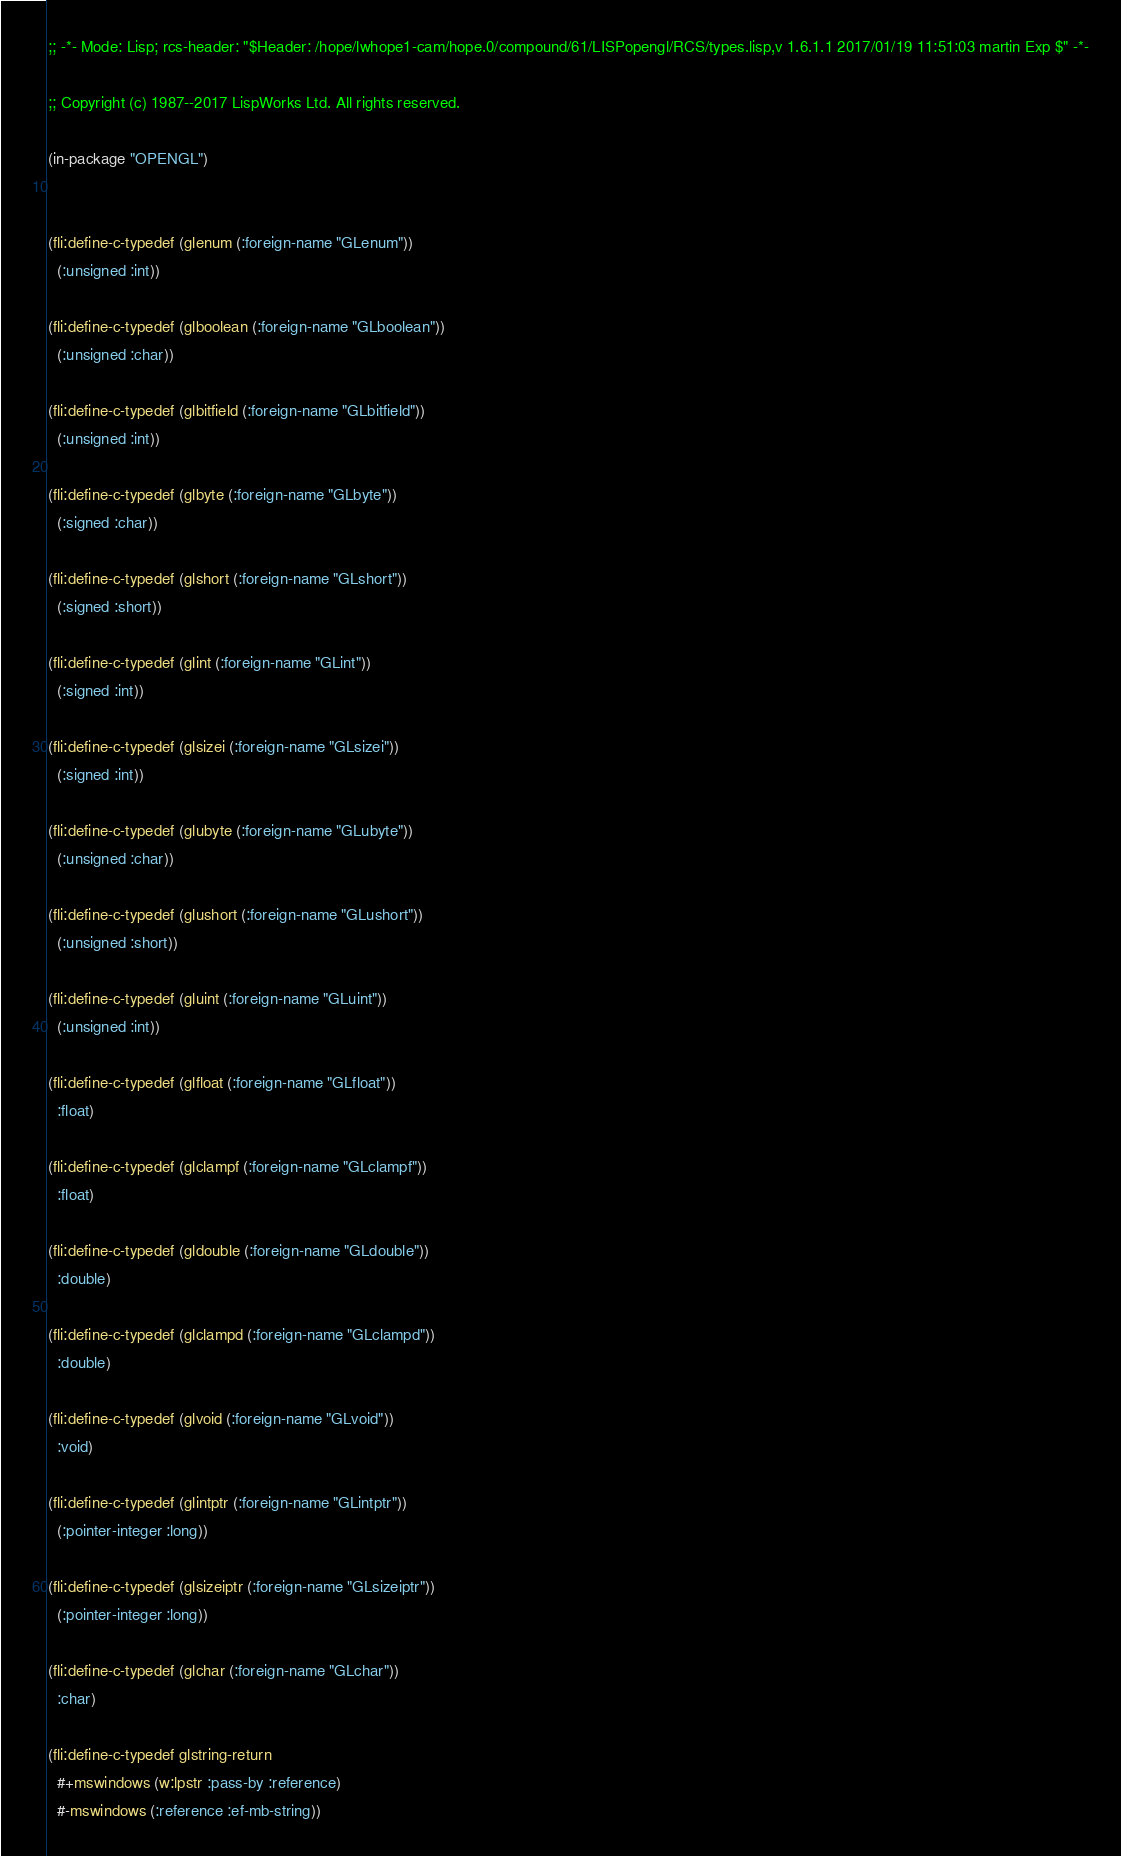<code> <loc_0><loc_0><loc_500><loc_500><_Lisp_>;; -*- Mode: Lisp; rcs-header: "$Header: /hope/lwhope1-cam/hope.0/compound/61/LISPopengl/RCS/types.lisp,v 1.6.1.1 2017/01/19 11:51:03 martin Exp $" -*-

;; Copyright (c) 1987--2017 LispWorks Ltd. All rights reserved.

(in-package "OPENGL")


(fli:define-c-typedef (glenum (:foreign-name "GLenum"))
  (:unsigned :int))

(fli:define-c-typedef (glboolean (:foreign-name "GLboolean"))
  (:unsigned :char))

(fli:define-c-typedef (glbitfield (:foreign-name "GLbitfield"))
  (:unsigned :int))

(fli:define-c-typedef (glbyte (:foreign-name "GLbyte"))
  (:signed :char))

(fli:define-c-typedef (glshort (:foreign-name "GLshort"))
  (:signed :short))

(fli:define-c-typedef (glint (:foreign-name "GLint"))
  (:signed :int))

(fli:define-c-typedef (glsizei (:foreign-name "GLsizei"))
  (:signed :int))

(fli:define-c-typedef (glubyte (:foreign-name "GLubyte"))
  (:unsigned :char))

(fli:define-c-typedef (glushort (:foreign-name "GLushort"))
  (:unsigned :short))

(fli:define-c-typedef (gluint (:foreign-name "GLuint"))
  (:unsigned :int))

(fli:define-c-typedef (glfloat (:foreign-name "GLfloat"))
  :float)

(fli:define-c-typedef (glclampf (:foreign-name "GLclampf"))
  :float)

(fli:define-c-typedef (gldouble (:foreign-name "GLdouble"))
  :double)

(fli:define-c-typedef (glclampd (:foreign-name "GLclampd"))
  :double)

(fli:define-c-typedef (glvoid (:foreign-name "GLvoid"))
  :void)

(fli:define-c-typedef (glintptr (:foreign-name "GLintptr"))
  (:pointer-integer :long))

(fli:define-c-typedef (glsizeiptr (:foreign-name "GLsizeiptr"))
  (:pointer-integer :long))

(fli:define-c-typedef (glchar (:foreign-name "GLchar"))
  :char)

(fli:define-c-typedef glstring-return
  #+mswindows (w:lpstr :pass-by :reference)
  #-mswindows (:reference :ef-mb-string))

</code> 